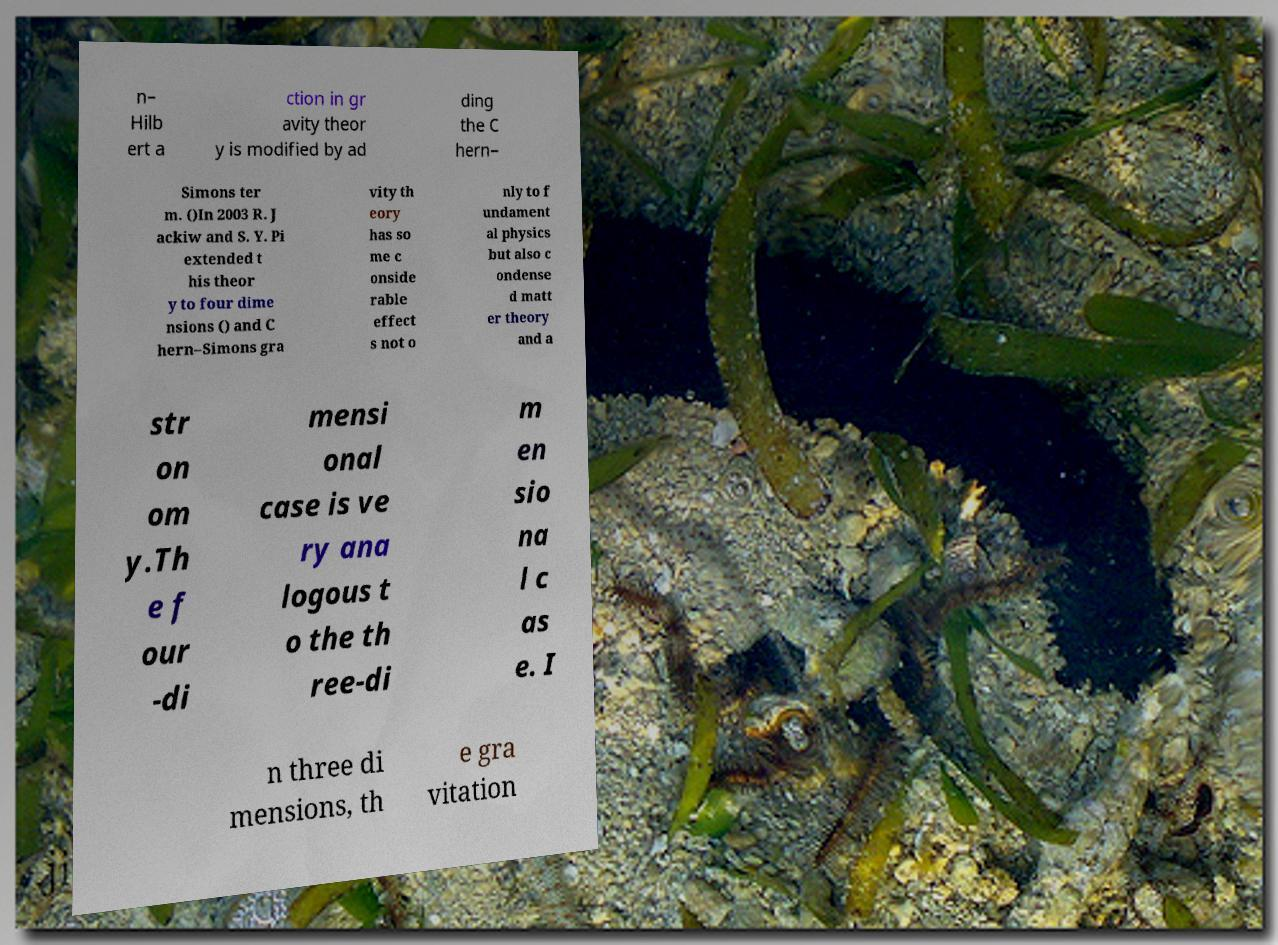Please read and relay the text visible in this image. What does it say? n– Hilb ert a ction in gr avity theor y is modified by ad ding the C hern– Simons ter m. ()In 2003 R. J ackiw and S. Y. Pi extended t his theor y to four dime nsions () and C hern–Simons gra vity th eory has so me c onside rable effect s not o nly to f undament al physics but also c ondense d matt er theory and a str on om y.Th e f our -di mensi onal case is ve ry ana logous t o the th ree-di m en sio na l c as e. I n three di mensions, th e gra vitation 